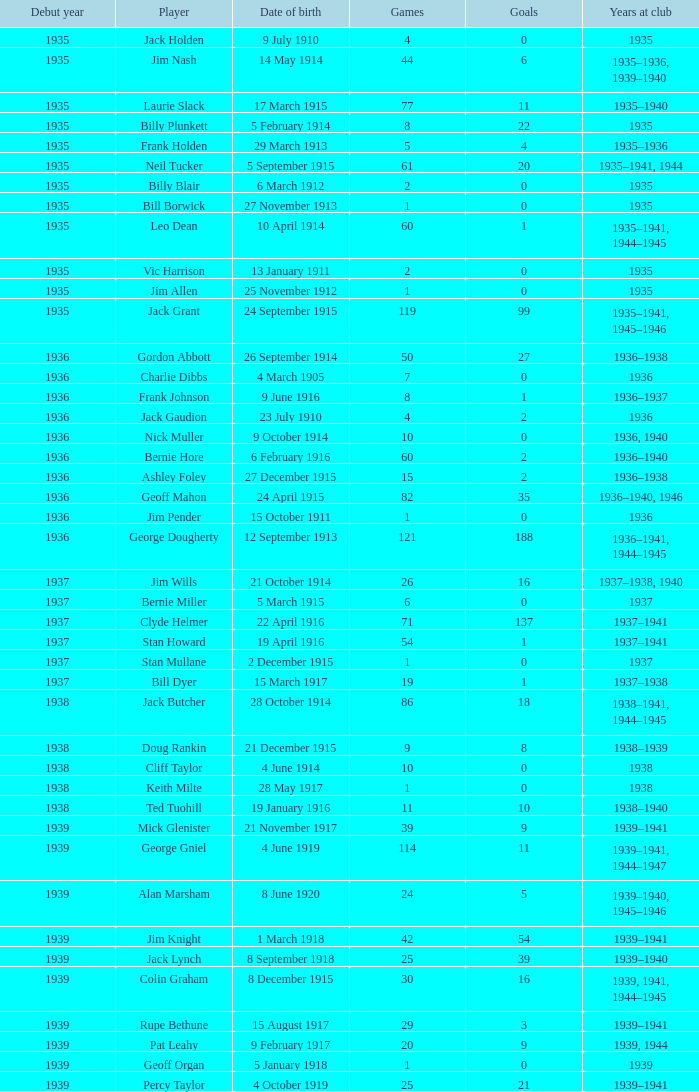What is the years at the club of the player with 2 goals and was born on 23 July 1910? 1936.0. Could you parse the entire table as a dict? {'header': ['Debut year', 'Player', 'Date of birth', 'Games', 'Goals', 'Years at club'], 'rows': [['1935', 'Jack Holden', '9 July 1910', '4', '0', '1935'], ['1935', 'Jim Nash', '14 May 1914', '44', '6', '1935–1936, 1939–1940'], ['1935', 'Laurie Slack', '17 March 1915', '77', '11', '1935–1940'], ['1935', 'Billy Plunkett', '5 February 1914', '8', '22', '1935'], ['1935', 'Frank Holden', '29 March 1913', '5', '4', '1935–1936'], ['1935', 'Neil Tucker', '5 September 1915', '61', '20', '1935–1941, 1944'], ['1935', 'Billy Blair', '6 March 1912', '2', '0', '1935'], ['1935', 'Bill Borwick', '27 November 1913', '1', '0', '1935'], ['1935', 'Leo Dean', '10 April 1914', '60', '1', '1935–1941, 1944–1945'], ['1935', 'Vic Harrison', '13 January 1911', '2', '0', '1935'], ['1935', 'Jim Allen', '25 November 1912', '1', '0', '1935'], ['1935', 'Jack Grant', '24 September 1915', '119', '99', '1935–1941, 1945–1946'], ['1936', 'Gordon Abbott', '26 September 1914', '50', '27', '1936–1938'], ['1936', 'Charlie Dibbs', '4 March 1905', '7', '0', '1936'], ['1936', 'Frank Johnson', '9 June 1916', '8', '1', '1936–1937'], ['1936', 'Jack Gaudion', '23 July 1910', '4', '2', '1936'], ['1936', 'Nick Muller', '9 October 1914', '10', '0', '1936, 1940'], ['1936', 'Bernie Hore', '6 February 1916', '60', '2', '1936–1940'], ['1936', 'Ashley Foley', '27 December 1915', '15', '2', '1936–1938'], ['1936', 'Geoff Mahon', '24 April 1915', '82', '35', '1936–1940, 1946'], ['1936', 'Jim Pender', '15 October 1911', '1', '0', '1936'], ['1936', 'George Dougherty', '12 September 1913', '121', '188', '1936–1941, 1944–1945'], ['1937', 'Jim Wills', '21 October 1914', '26', '16', '1937–1938, 1940'], ['1937', 'Bernie Miller', '5 March 1915', '6', '0', '1937'], ['1937', 'Clyde Helmer', '22 April 1916', '71', '137', '1937–1941'], ['1937', 'Stan Howard', '19 April 1916', '54', '1', '1937–1941'], ['1937', 'Stan Mullane', '2 December 1915', '1', '0', '1937'], ['1937', 'Bill Dyer', '15 March 1917', '19', '1', '1937–1938'], ['1938', 'Jack Butcher', '28 October 1914', '86', '18', '1938–1941, 1944–1945'], ['1938', 'Doug Rankin', '21 December 1915', '9', '8', '1938–1939'], ['1938', 'Cliff Taylor', '4 June 1914', '10', '0', '1938'], ['1938', 'Keith Milte', '28 May 1917', '1', '0', '1938'], ['1938', 'Ted Tuohill', '19 January 1916', '11', '10', '1938–1940'], ['1939', 'Mick Glenister', '21 November 1917', '39', '9', '1939–1941'], ['1939', 'George Gniel', '4 June 1919', '114', '11', '1939–1941, 1944–1947'], ['1939', 'Alan Marsham', '8 June 1920', '24', '5', '1939–1940, 1945–1946'], ['1939', 'Jim Knight', '1 March 1918', '42', '54', '1939–1941'], ['1939', 'Jack Lynch', '8 September 1918', '25', '39', '1939–1940'], ['1939', 'Colin Graham', '8 December 1915', '30', '16', '1939, 1941, 1944–1945'], ['1939', 'Rupe Bethune', '15 August 1917', '29', '3', '1939–1941'], ['1939', 'Pat Leahy', '9 February 1917', '20', '9', '1939, 1944'], ['1939', 'Geoff Organ', '5 January 1918', '1', '0', '1939'], ['1939', 'Percy Taylor', '4 October 1919', '25', '21', '1939–1941']]} 